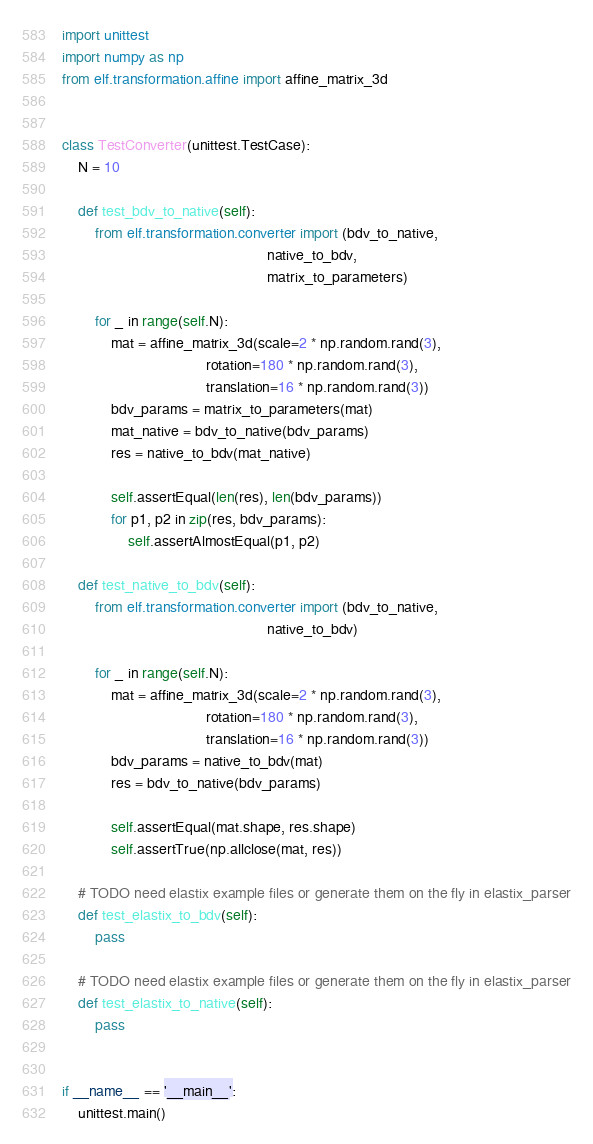Convert code to text. <code><loc_0><loc_0><loc_500><loc_500><_Python_>import unittest
import numpy as np
from elf.transformation.affine import affine_matrix_3d


class TestConverter(unittest.TestCase):
    N = 10

    def test_bdv_to_native(self):
        from elf.transformation.converter import (bdv_to_native,
                                                  native_to_bdv,
                                                  matrix_to_parameters)

        for _ in range(self.N):
            mat = affine_matrix_3d(scale=2 * np.random.rand(3),
                                   rotation=180 * np.random.rand(3),
                                   translation=16 * np.random.rand(3))
            bdv_params = matrix_to_parameters(mat)
            mat_native = bdv_to_native(bdv_params)
            res = native_to_bdv(mat_native)

            self.assertEqual(len(res), len(bdv_params))
            for p1, p2 in zip(res, bdv_params):
                self.assertAlmostEqual(p1, p2)

    def test_native_to_bdv(self):
        from elf.transformation.converter import (bdv_to_native,
                                                  native_to_bdv)

        for _ in range(self.N):
            mat = affine_matrix_3d(scale=2 * np.random.rand(3),
                                   rotation=180 * np.random.rand(3),
                                   translation=16 * np.random.rand(3))
            bdv_params = native_to_bdv(mat)
            res = bdv_to_native(bdv_params)

            self.assertEqual(mat.shape, res.shape)
            self.assertTrue(np.allclose(mat, res))

    # TODO need elastix example files or generate them on the fly in elastix_parser
    def test_elastix_to_bdv(self):
        pass

    # TODO need elastix example files or generate them on the fly in elastix_parser
    def test_elastix_to_native(self):
        pass


if __name__ == '__main__':
    unittest.main()
</code> 